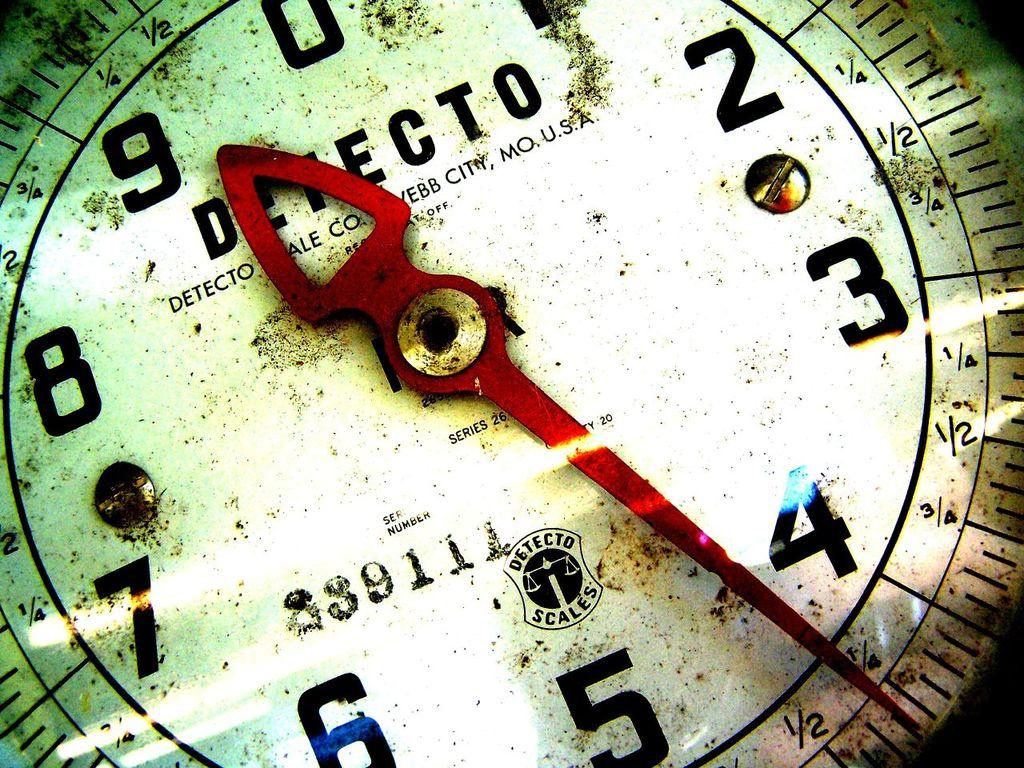<image>
Offer a succinct explanation of the picture presented. A white scale with text "DETECTO DETECTO SCALE CO. WEBB CITY, MO. U.S.A" and red pointer. 